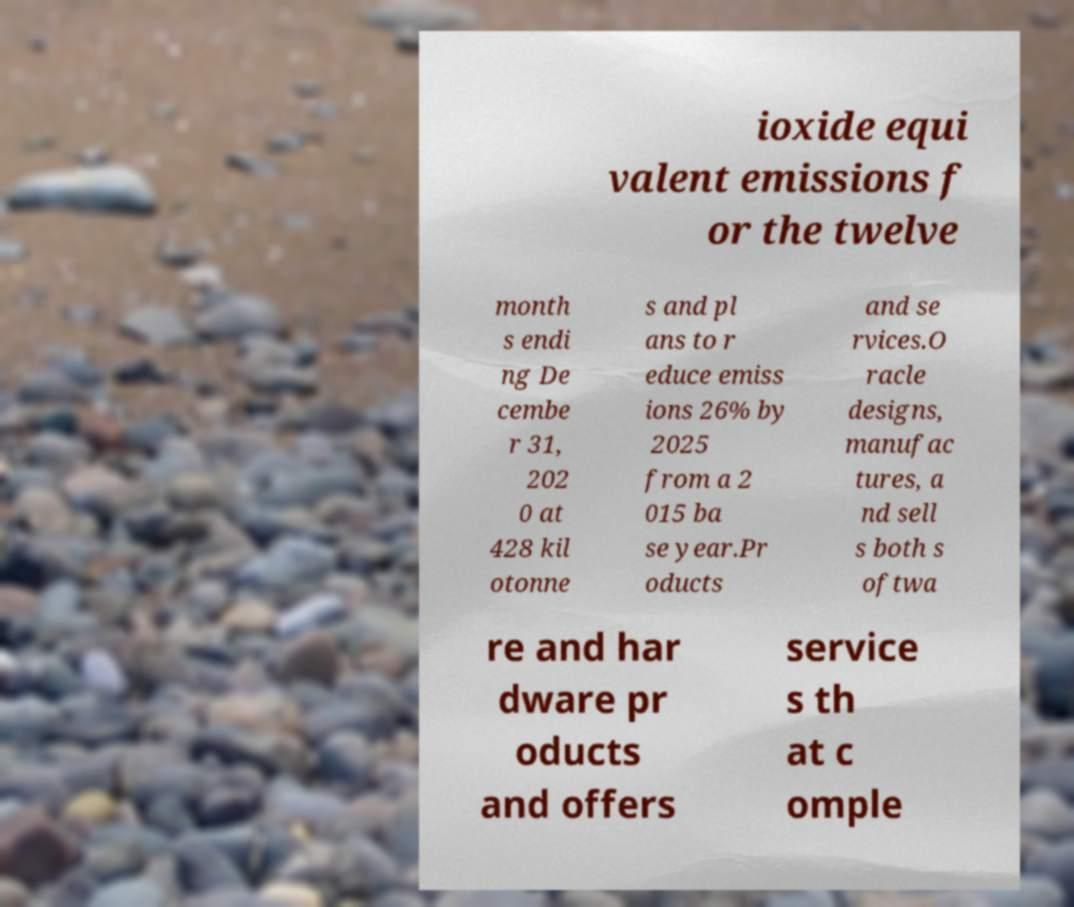For documentation purposes, I need the text within this image transcribed. Could you provide that? ioxide equi valent emissions f or the twelve month s endi ng De cembe r 31, 202 0 at 428 kil otonne s and pl ans to r educe emiss ions 26% by 2025 from a 2 015 ba se year.Pr oducts and se rvices.O racle designs, manufac tures, a nd sell s both s oftwa re and har dware pr oducts and offers service s th at c omple 